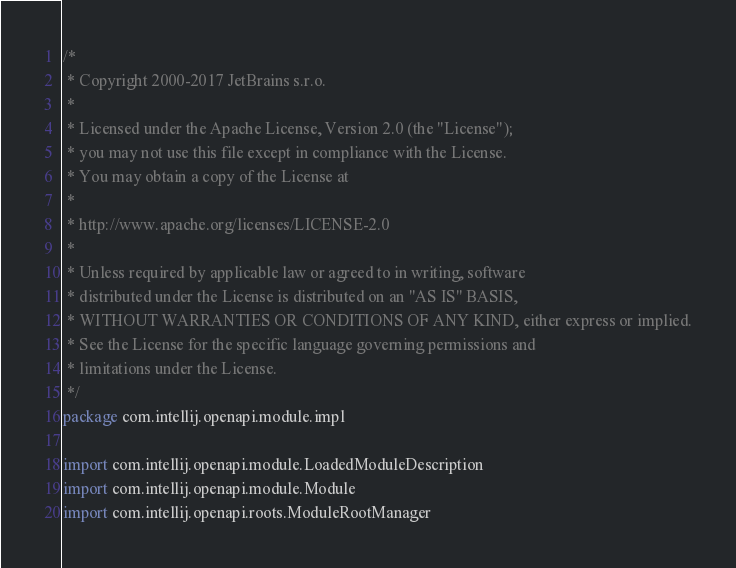Convert code to text. <code><loc_0><loc_0><loc_500><loc_500><_Kotlin_>/*
 * Copyright 2000-2017 JetBrains s.r.o.
 *
 * Licensed under the Apache License, Version 2.0 (the "License");
 * you may not use this file except in compliance with the License.
 * You may obtain a copy of the License at
 *
 * http://www.apache.org/licenses/LICENSE-2.0
 *
 * Unless required by applicable law or agreed to in writing, software
 * distributed under the License is distributed on an "AS IS" BASIS,
 * WITHOUT WARRANTIES OR CONDITIONS OF ANY KIND, either express or implied.
 * See the License for the specific language governing permissions and
 * limitations under the License.
 */
package com.intellij.openapi.module.impl

import com.intellij.openapi.module.LoadedModuleDescription
import com.intellij.openapi.module.Module
import com.intellij.openapi.roots.ModuleRootManager
</code> 